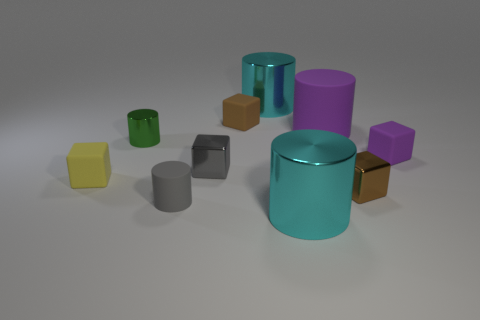What is the material of the large purple object that is the same shape as the gray rubber thing?
Your answer should be compact. Rubber. Are there fewer cyan objects than tiny red shiny spheres?
Your answer should be very brief. No. Is the color of the shiny cube behind the yellow cube the same as the tiny matte cylinder?
Provide a succinct answer. Yes. What color is the tiny cylinder that is the same material as the yellow block?
Provide a succinct answer. Gray. Does the brown matte object have the same size as the yellow rubber object?
Keep it short and to the point. Yes. What is the material of the purple cylinder?
Your answer should be compact. Rubber. There is a purple object that is the same size as the green cylinder; what material is it?
Give a very brief answer. Rubber. Is there a gray matte cylinder that has the same size as the gray matte thing?
Offer a terse response. No. Are there the same number of metallic things behind the green object and purple matte objects behind the purple cube?
Keep it short and to the point. Yes. Is the number of tiny brown rubber objects greater than the number of large cylinders?
Your response must be concise. No. 